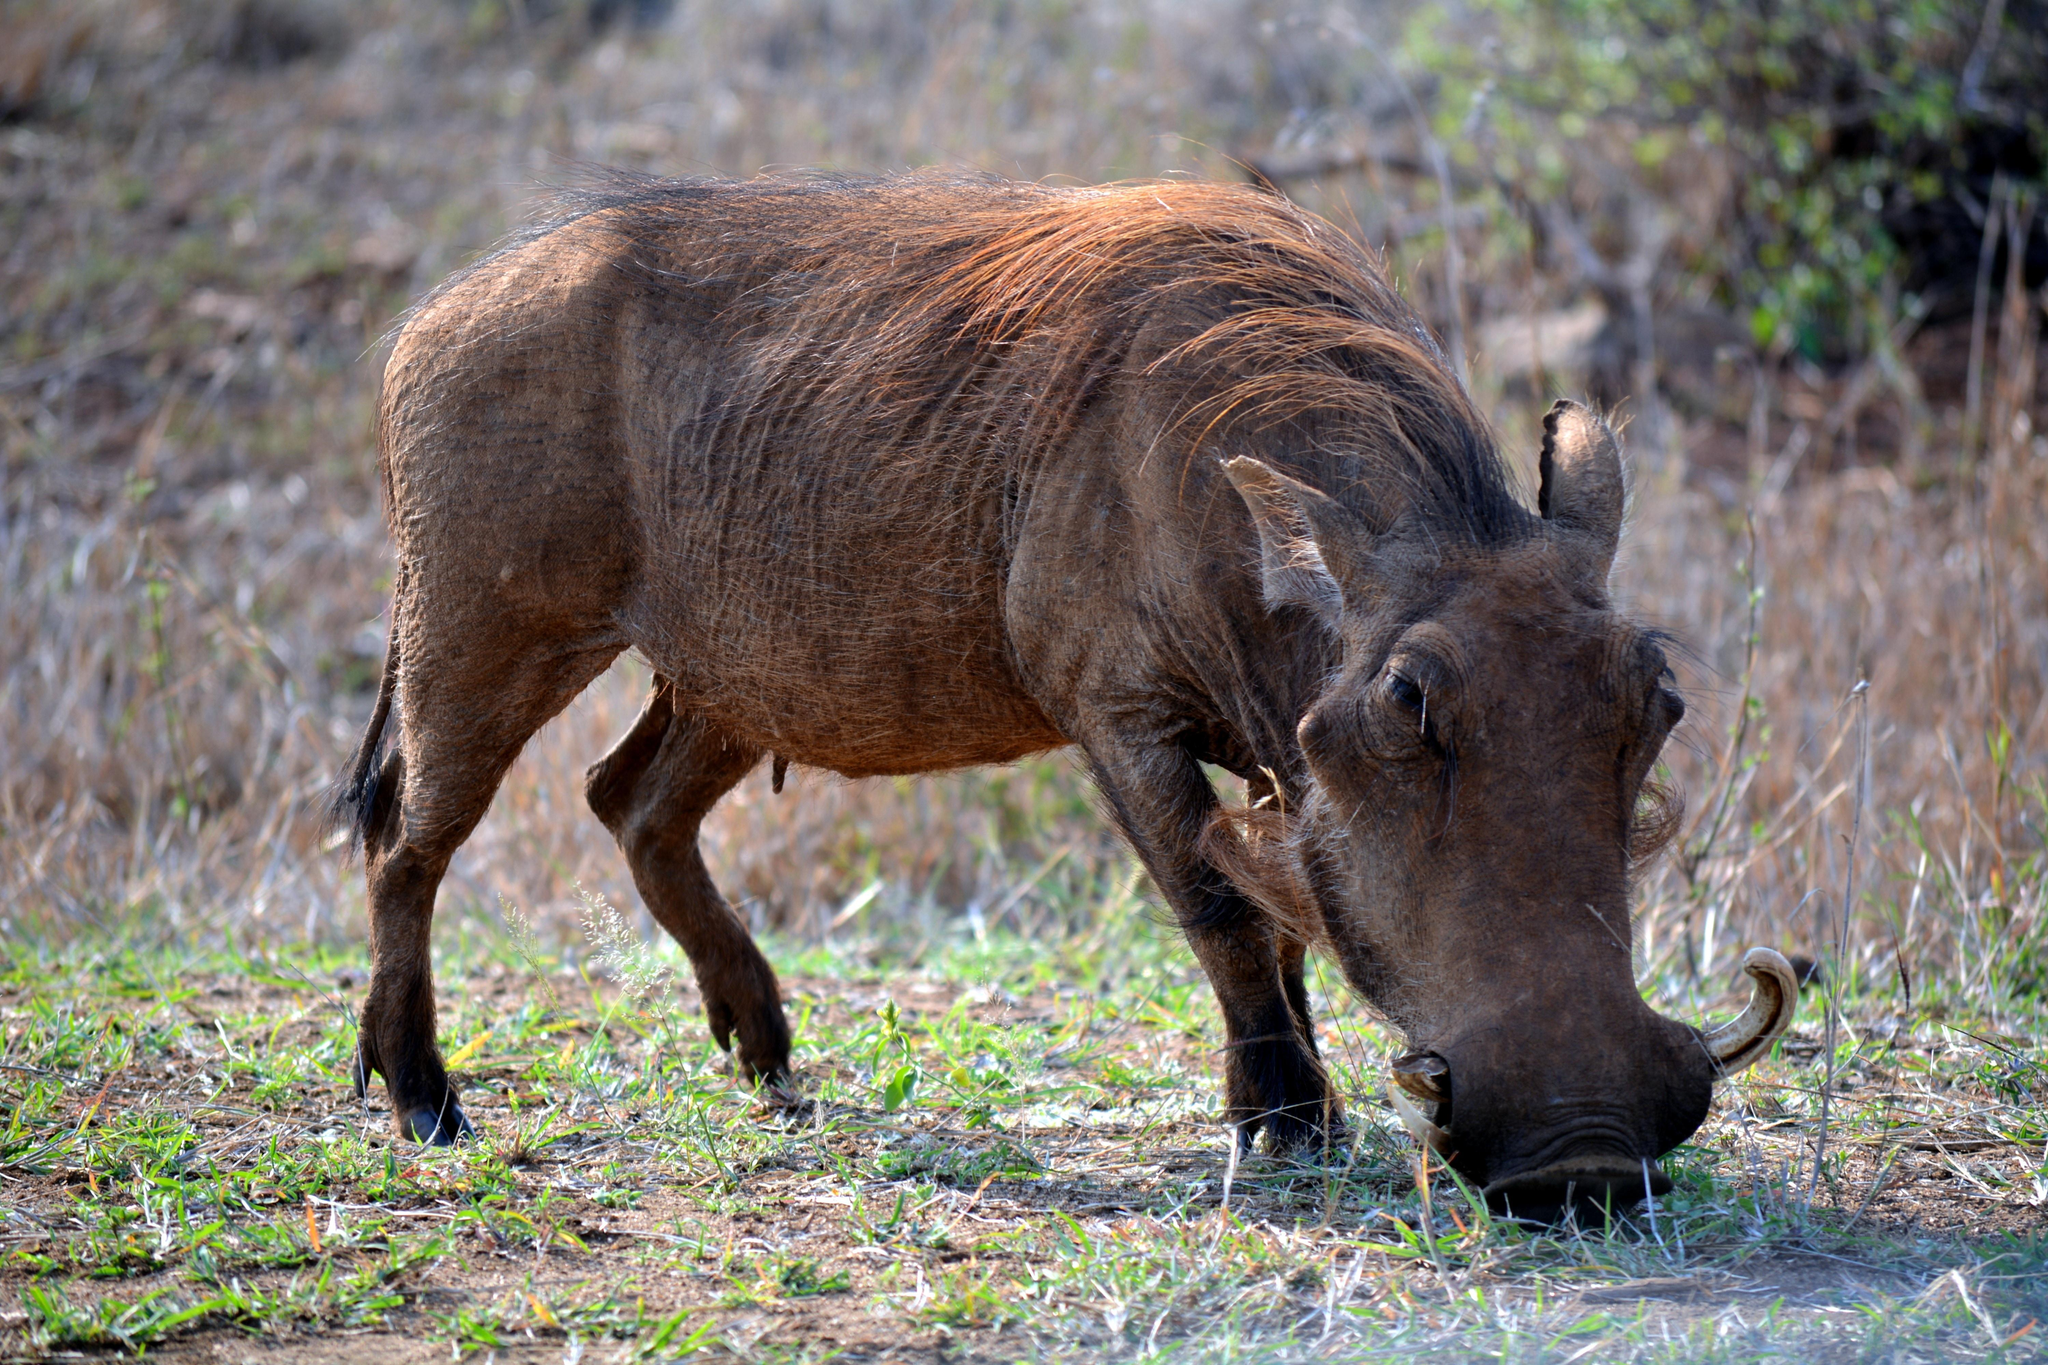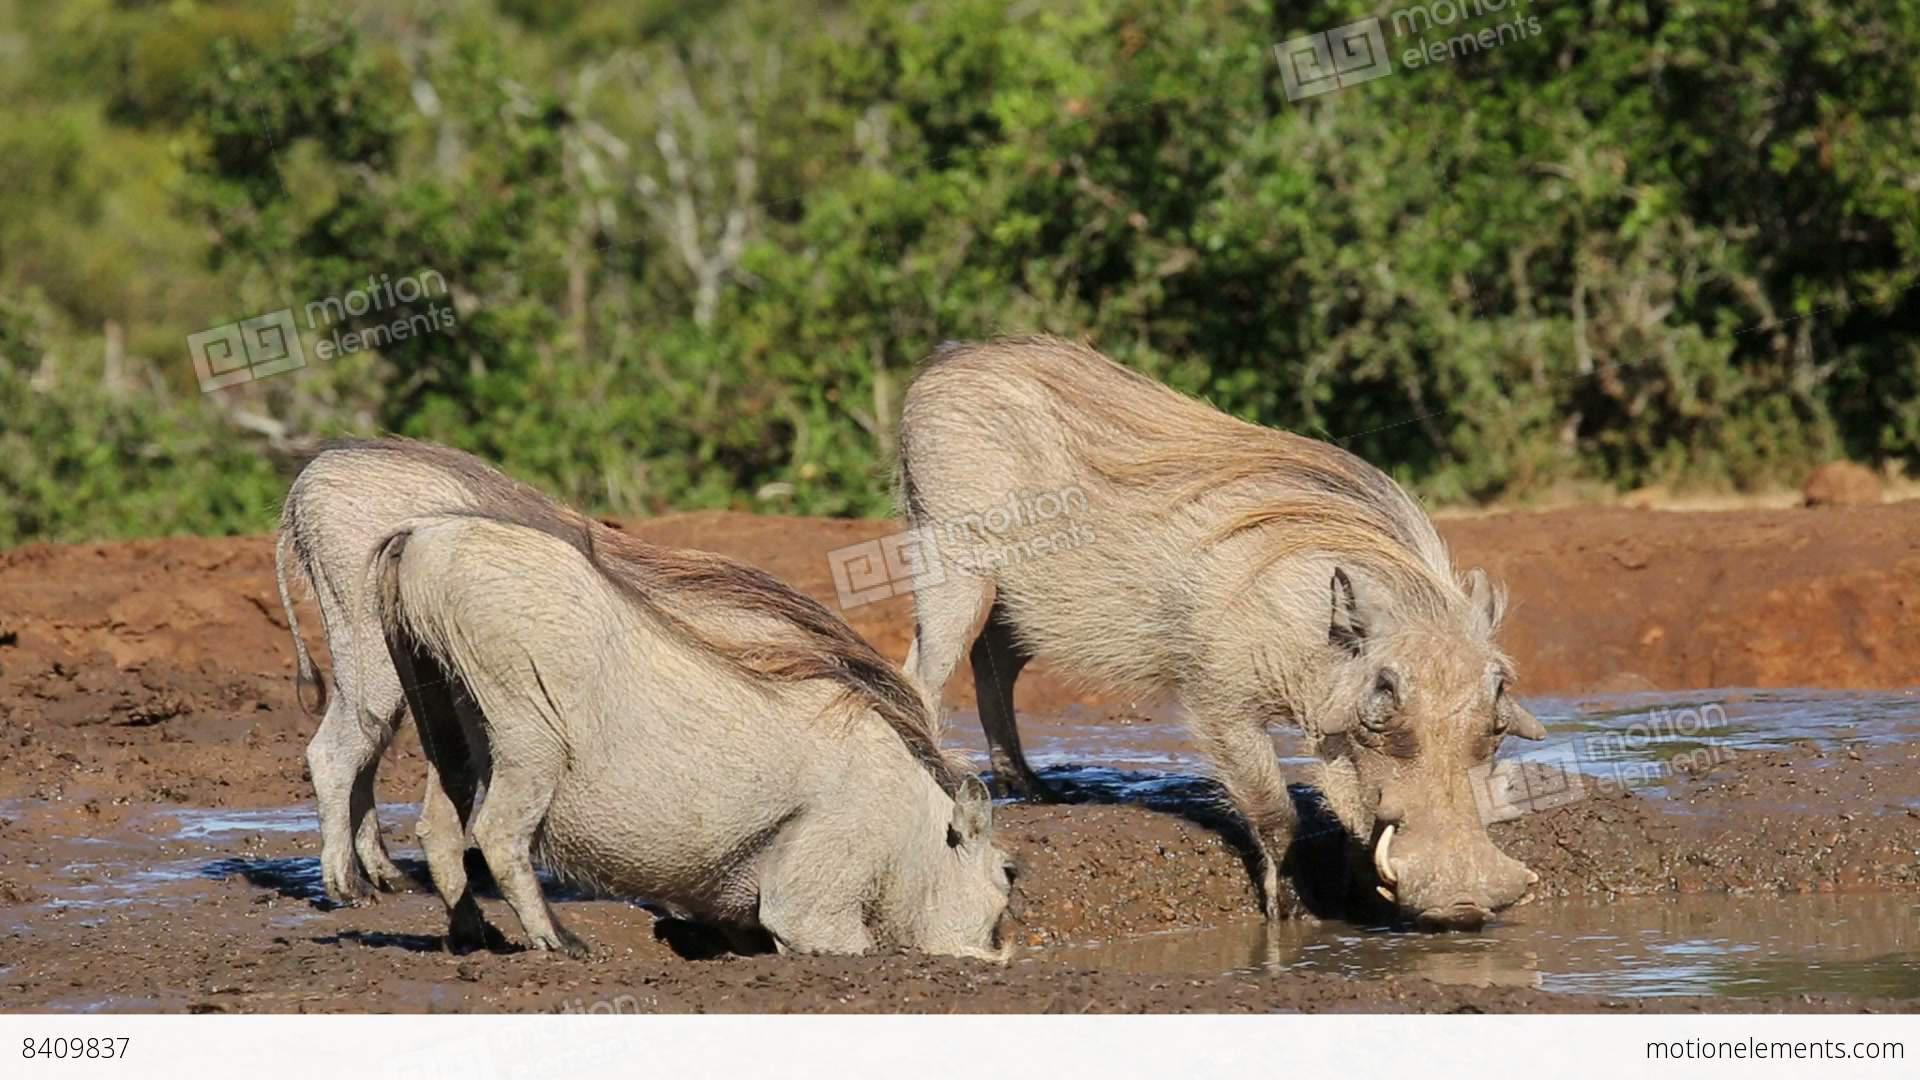The first image is the image on the left, the second image is the image on the right. Considering the images on both sides, is "There is no more than one warthog in the left image." valid? Answer yes or no. Yes. The first image is the image on the left, the second image is the image on the right. Examine the images to the left and right. Is the description "Multiple warthogs stand at the edge of a muddy hole." accurate? Answer yes or no. Yes. 